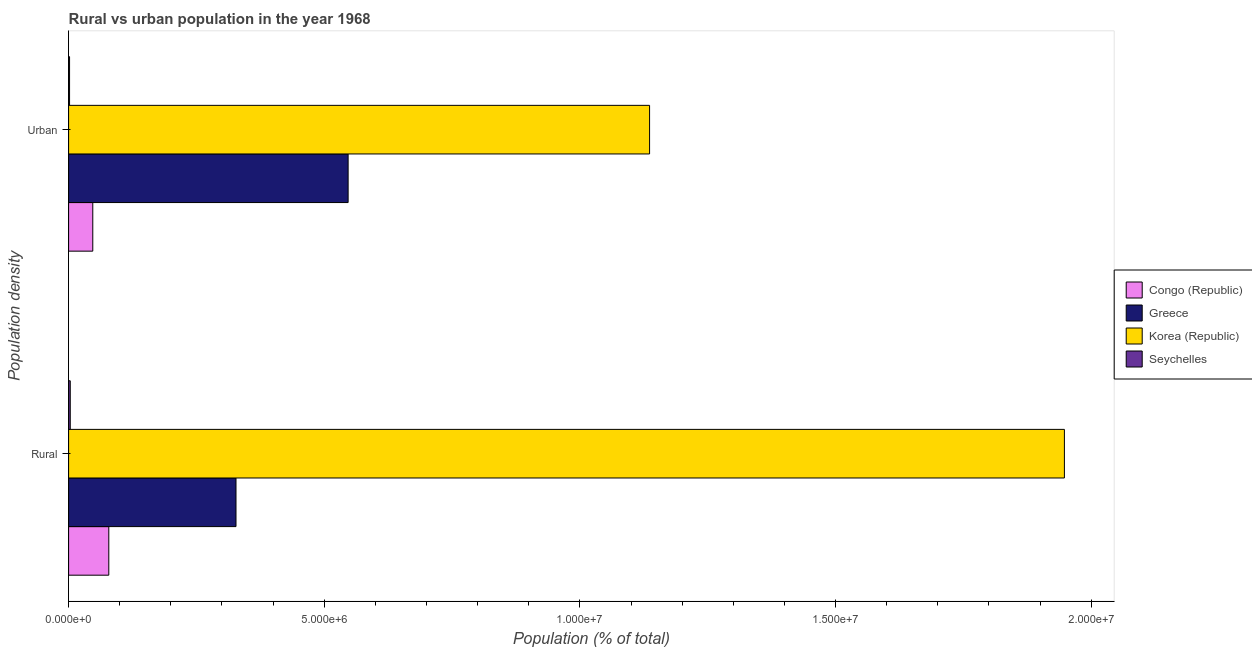Are the number of bars per tick equal to the number of legend labels?
Provide a short and direct response. Yes. Are the number of bars on each tick of the Y-axis equal?
Your response must be concise. Yes. How many bars are there on the 1st tick from the bottom?
Keep it short and to the point. 4. What is the label of the 2nd group of bars from the top?
Provide a short and direct response. Rural. What is the urban population density in Greece?
Keep it short and to the point. 5.47e+06. Across all countries, what is the maximum urban population density?
Ensure brevity in your answer.  1.14e+07. Across all countries, what is the minimum rural population density?
Offer a very short reply. 3.24e+04. In which country was the urban population density minimum?
Give a very brief answer. Seychelles. What is the total urban population density in the graph?
Your response must be concise. 1.73e+07. What is the difference between the urban population density in Korea (Republic) and that in Congo (Republic)?
Your answer should be very brief. 1.09e+07. What is the difference between the rural population density in Congo (Republic) and the urban population density in Korea (Republic)?
Ensure brevity in your answer.  -1.06e+07. What is the average rural population density per country?
Offer a very short reply. 5.89e+06. What is the difference between the rural population density and urban population density in Greece?
Provide a succinct answer. -2.19e+06. In how many countries, is the rural population density greater than 12000000 %?
Your response must be concise. 1. What is the ratio of the rural population density in Congo (Republic) to that in Seychelles?
Your answer should be compact. 24.26. What does the 4th bar from the top in Urban represents?
Your response must be concise. Congo (Republic). What does the 2nd bar from the bottom in Rural represents?
Keep it short and to the point. Greece. How many bars are there?
Your answer should be compact. 8. What is the difference between two consecutive major ticks on the X-axis?
Your answer should be compact. 5.00e+06. How are the legend labels stacked?
Provide a succinct answer. Vertical. What is the title of the graph?
Offer a terse response. Rural vs urban population in the year 1968. Does "Portugal" appear as one of the legend labels in the graph?
Ensure brevity in your answer.  No. What is the label or title of the X-axis?
Provide a short and direct response. Population (% of total). What is the label or title of the Y-axis?
Your answer should be very brief. Population density. What is the Population (% of total) of Congo (Republic) in Rural?
Offer a very short reply. 7.86e+05. What is the Population (% of total) in Greece in Rural?
Keep it short and to the point. 3.27e+06. What is the Population (% of total) in Korea (Republic) in Rural?
Offer a very short reply. 1.95e+07. What is the Population (% of total) in Seychelles in Rural?
Keep it short and to the point. 3.24e+04. What is the Population (% of total) of Congo (Republic) in Urban?
Keep it short and to the point. 4.73e+05. What is the Population (% of total) in Greece in Urban?
Your response must be concise. 5.47e+06. What is the Population (% of total) of Korea (Republic) in Urban?
Your response must be concise. 1.14e+07. What is the Population (% of total) of Seychelles in Urban?
Your response must be concise. 1.87e+04. Across all Population density, what is the maximum Population (% of total) in Congo (Republic)?
Offer a very short reply. 7.86e+05. Across all Population density, what is the maximum Population (% of total) in Greece?
Your response must be concise. 5.47e+06. Across all Population density, what is the maximum Population (% of total) of Korea (Republic)?
Provide a short and direct response. 1.95e+07. Across all Population density, what is the maximum Population (% of total) in Seychelles?
Offer a very short reply. 3.24e+04. Across all Population density, what is the minimum Population (% of total) in Congo (Republic)?
Your answer should be compact. 4.73e+05. Across all Population density, what is the minimum Population (% of total) of Greece?
Your response must be concise. 3.27e+06. Across all Population density, what is the minimum Population (% of total) of Korea (Republic)?
Offer a very short reply. 1.14e+07. Across all Population density, what is the minimum Population (% of total) of Seychelles?
Your answer should be very brief. 1.87e+04. What is the total Population (% of total) in Congo (Republic) in the graph?
Your response must be concise. 1.26e+06. What is the total Population (% of total) of Greece in the graph?
Your answer should be very brief. 8.74e+06. What is the total Population (% of total) of Korea (Republic) in the graph?
Provide a short and direct response. 3.08e+07. What is the total Population (% of total) of Seychelles in the graph?
Keep it short and to the point. 5.11e+04. What is the difference between the Population (% of total) in Congo (Republic) in Rural and that in Urban?
Provide a short and direct response. 3.13e+05. What is the difference between the Population (% of total) of Greece in Rural and that in Urban?
Make the answer very short. -2.19e+06. What is the difference between the Population (% of total) of Korea (Republic) in Rural and that in Urban?
Make the answer very short. 8.11e+06. What is the difference between the Population (% of total) in Seychelles in Rural and that in Urban?
Make the answer very short. 1.37e+04. What is the difference between the Population (% of total) of Congo (Republic) in Rural and the Population (% of total) of Greece in Urban?
Your answer should be compact. -4.68e+06. What is the difference between the Population (% of total) in Congo (Republic) in Rural and the Population (% of total) in Korea (Republic) in Urban?
Provide a short and direct response. -1.06e+07. What is the difference between the Population (% of total) of Congo (Republic) in Rural and the Population (% of total) of Seychelles in Urban?
Keep it short and to the point. 7.67e+05. What is the difference between the Population (% of total) in Greece in Rural and the Population (% of total) in Korea (Republic) in Urban?
Provide a succinct answer. -8.09e+06. What is the difference between the Population (% of total) of Greece in Rural and the Population (% of total) of Seychelles in Urban?
Make the answer very short. 3.26e+06. What is the difference between the Population (% of total) of Korea (Republic) in Rural and the Population (% of total) of Seychelles in Urban?
Ensure brevity in your answer.  1.95e+07. What is the average Population (% of total) in Congo (Republic) per Population density?
Keep it short and to the point. 6.30e+05. What is the average Population (% of total) in Greece per Population density?
Keep it short and to the point. 4.37e+06. What is the average Population (% of total) of Korea (Republic) per Population density?
Your answer should be very brief. 1.54e+07. What is the average Population (% of total) of Seychelles per Population density?
Provide a short and direct response. 2.56e+04. What is the difference between the Population (% of total) of Congo (Republic) and Population (% of total) of Greece in Rural?
Provide a succinct answer. -2.49e+06. What is the difference between the Population (% of total) in Congo (Republic) and Population (% of total) in Korea (Republic) in Rural?
Provide a short and direct response. -1.87e+07. What is the difference between the Population (% of total) of Congo (Republic) and Population (% of total) of Seychelles in Rural?
Make the answer very short. 7.54e+05. What is the difference between the Population (% of total) in Greece and Population (% of total) in Korea (Republic) in Rural?
Keep it short and to the point. -1.62e+07. What is the difference between the Population (% of total) of Greece and Population (% of total) of Seychelles in Rural?
Provide a short and direct response. 3.24e+06. What is the difference between the Population (% of total) of Korea (Republic) and Population (% of total) of Seychelles in Rural?
Ensure brevity in your answer.  1.94e+07. What is the difference between the Population (% of total) in Congo (Republic) and Population (% of total) in Greece in Urban?
Give a very brief answer. -4.99e+06. What is the difference between the Population (% of total) in Congo (Republic) and Population (% of total) in Korea (Republic) in Urban?
Offer a terse response. -1.09e+07. What is the difference between the Population (% of total) in Congo (Republic) and Population (% of total) in Seychelles in Urban?
Provide a succinct answer. 4.54e+05. What is the difference between the Population (% of total) of Greece and Population (% of total) of Korea (Republic) in Urban?
Offer a very short reply. -5.90e+06. What is the difference between the Population (% of total) of Greece and Population (% of total) of Seychelles in Urban?
Offer a terse response. 5.45e+06. What is the difference between the Population (% of total) of Korea (Republic) and Population (% of total) of Seychelles in Urban?
Offer a very short reply. 1.13e+07. What is the ratio of the Population (% of total) of Congo (Republic) in Rural to that in Urban?
Keep it short and to the point. 1.66. What is the ratio of the Population (% of total) of Greece in Rural to that in Urban?
Make the answer very short. 0.6. What is the ratio of the Population (% of total) in Korea (Republic) in Rural to that in Urban?
Provide a succinct answer. 1.71. What is the ratio of the Population (% of total) of Seychelles in Rural to that in Urban?
Give a very brief answer. 1.73. What is the difference between the highest and the second highest Population (% of total) of Congo (Republic)?
Provide a short and direct response. 3.13e+05. What is the difference between the highest and the second highest Population (% of total) in Greece?
Offer a terse response. 2.19e+06. What is the difference between the highest and the second highest Population (% of total) of Korea (Republic)?
Your answer should be very brief. 8.11e+06. What is the difference between the highest and the second highest Population (% of total) in Seychelles?
Offer a very short reply. 1.37e+04. What is the difference between the highest and the lowest Population (% of total) in Congo (Republic)?
Ensure brevity in your answer.  3.13e+05. What is the difference between the highest and the lowest Population (% of total) in Greece?
Give a very brief answer. 2.19e+06. What is the difference between the highest and the lowest Population (% of total) of Korea (Republic)?
Offer a terse response. 8.11e+06. What is the difference between the highest and the lowest Population (% of total) in Seychelles?
Give a very brief answer. 1.37e+04. 